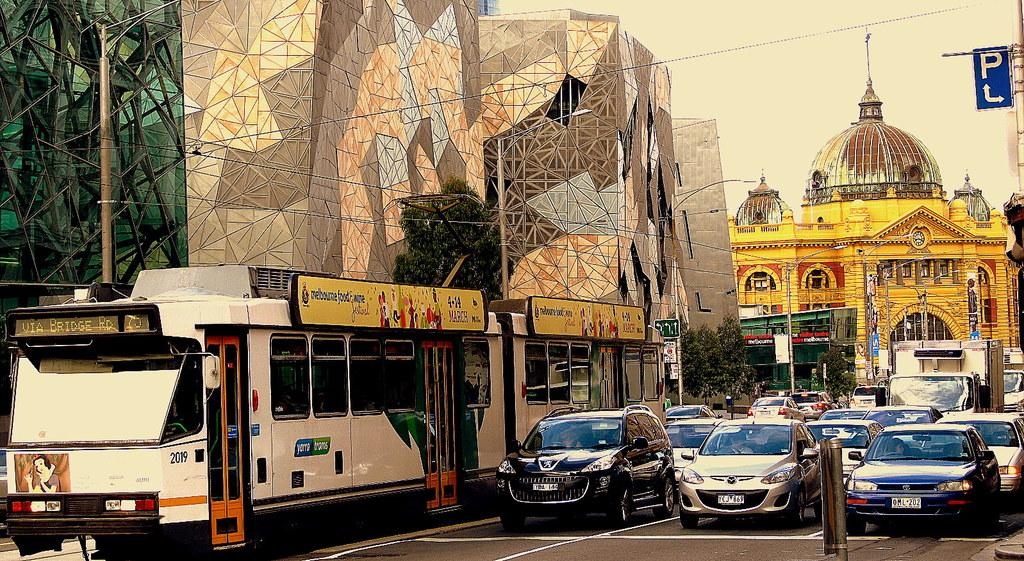<image>
Offer a succinct explanation of the picture presented. a traffic light stop, with the sign on a buss reading melbourne food and wine festival 